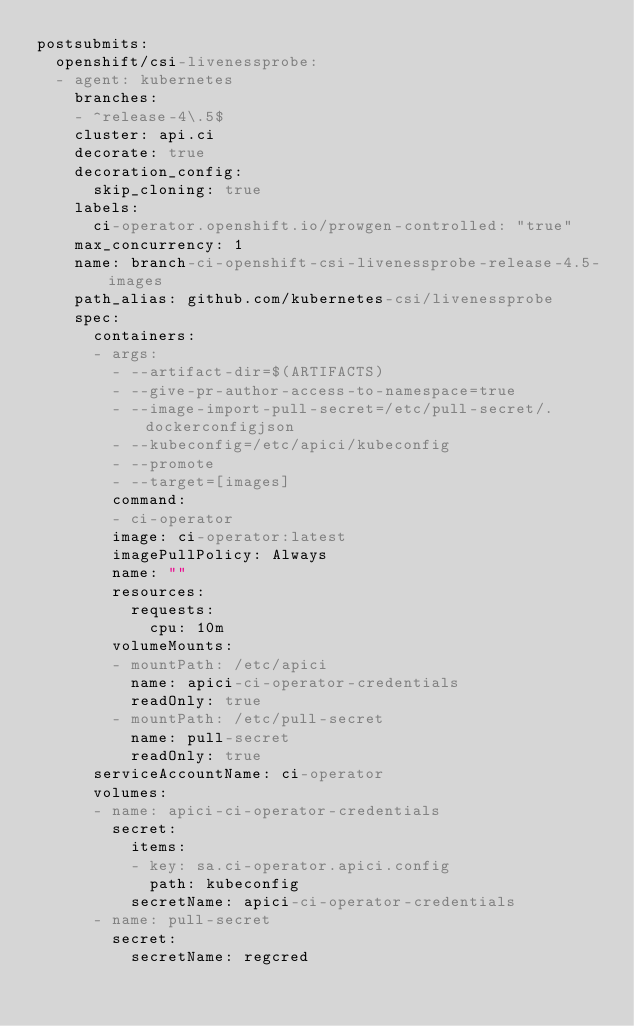<code> <loc_0><loc_0><loc_500><loc_500><_YAML_>postsubmits:
  openshift/csi-livenessprobe:
  - agent: kubernetes
    branches:
    - ^release-4\.5$
    cluster: api.ci
    decorate: true
    decoration_config:
      skip_cloning: true
    labels:
      ci-operator.openshift.io/prowgen-controlled: "true"
    max_concurrency: 1
    name: branch-ci-openshift-csi-livenessprobe-release-4.5-images
    path_alias: github.com/kubernetes-csi/livenessprobe
    spec:
      containers:
      - args:
        - --artifact-dir=$(ARTIFACTS)
        - --give-pr-author-access-to-namespace=true
        - --image-import-pull-secret=/etc/pull-secret/.dockerconfigjson
        - --kubeconfig=/etc/apici/kubeconfig
        - --promote
        - --target=[images]
        command:
        - ci-operator
        image: ci-operator:latest
        imagePullPolicy: Always
        name: ""
        resources:
          requests:
            cpu: 10m
        volumeMounts:
        - mountPath: /etc/apici
          name: apici-ci-operator-credentials
          readOnly: true
        - mountPath: /etc/pull-secret
          name: pull-secret
          readOnly: true
      serviceAccountName: ci-operator
      volumes:
      - name: apici-ci-operator-credentials
        secret:
          items:
          - key: sa.ci-operator.apici.config
            path: kubeconfig
          secretName: apici-ci-operator-credentials
      - name: pull-secret
        secret:
          secretName: regcred
</code> 